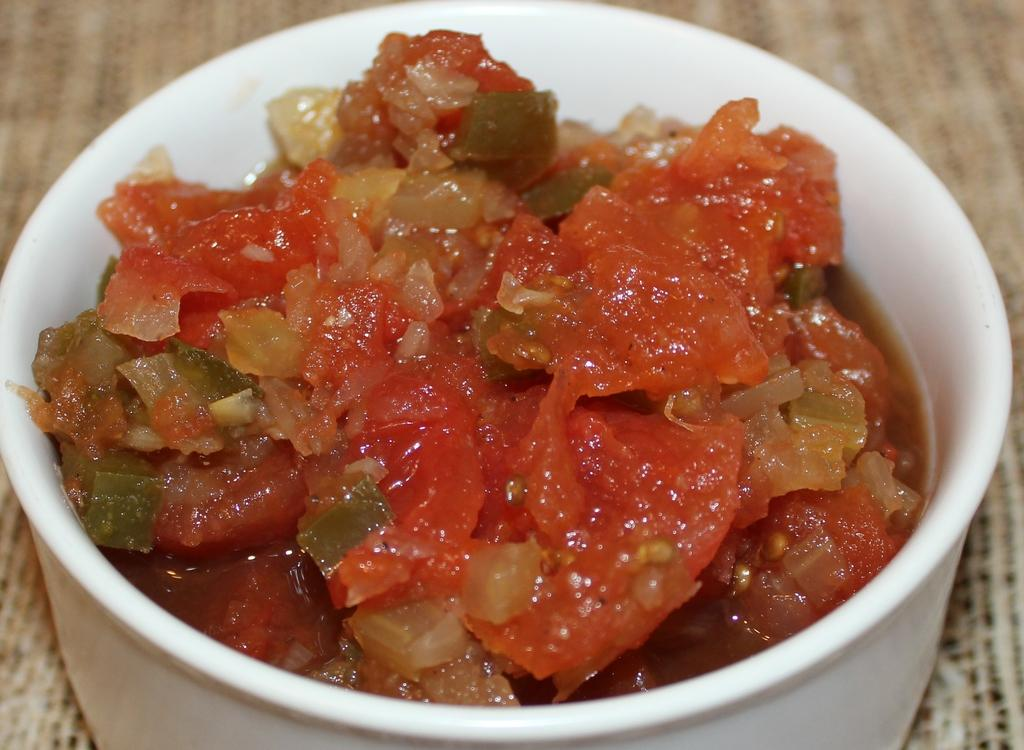What is in the bowl that is visible in the image? There is a bowl containing food in the image. Where is the bowl located in the image? The bowl is placed on a table. What type of powder can be seen floating in the ocean in the image? There is no ocean or powder present in the image; it only features a bowl containing food placed on a table. 